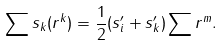<formula> <loc_0><loc_0><loc_500><loc_500>\sum s _ { k } ( r ^ { k } ) = \frac { 1 } { 2 } ( s _ { i } ^ { \prime } + s _ { k } ^ { \prime } ) \sum r ^ { m } .</formula> 